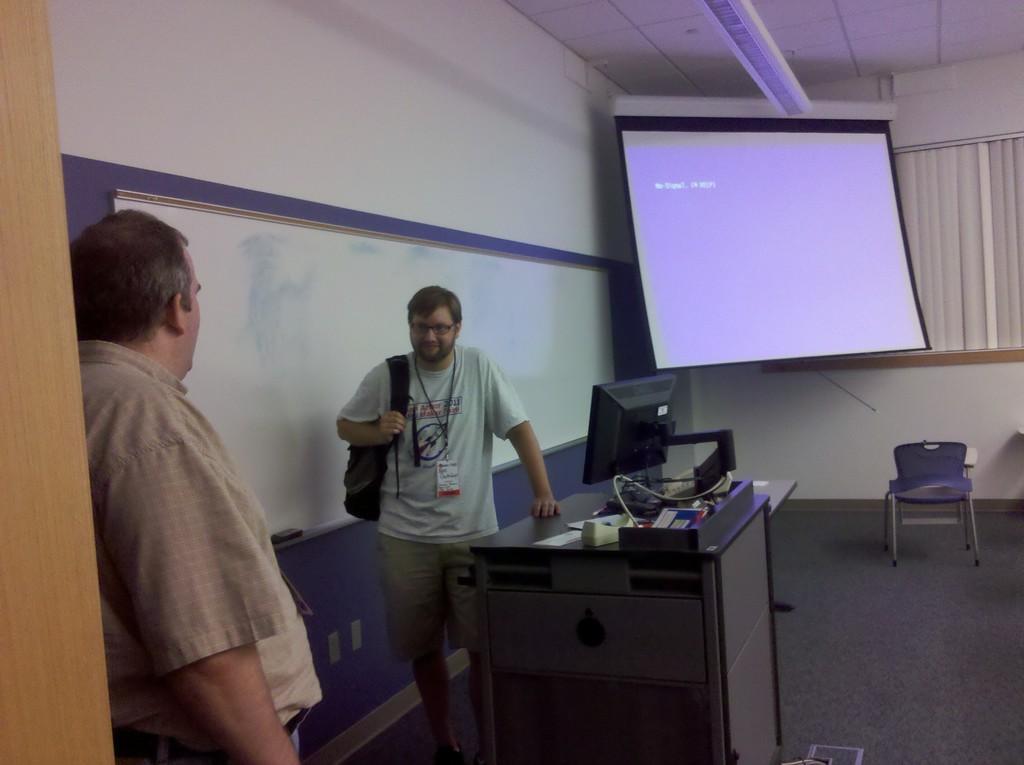Please provide a concise description of this image. In this image we can see two persons standing. One person is wearing specs and tag. And he is holding a bag. There is a cabinet. On the cabinet there is a computer and some other objects. In the back there is a chair. Also there is a screen and curtain. 